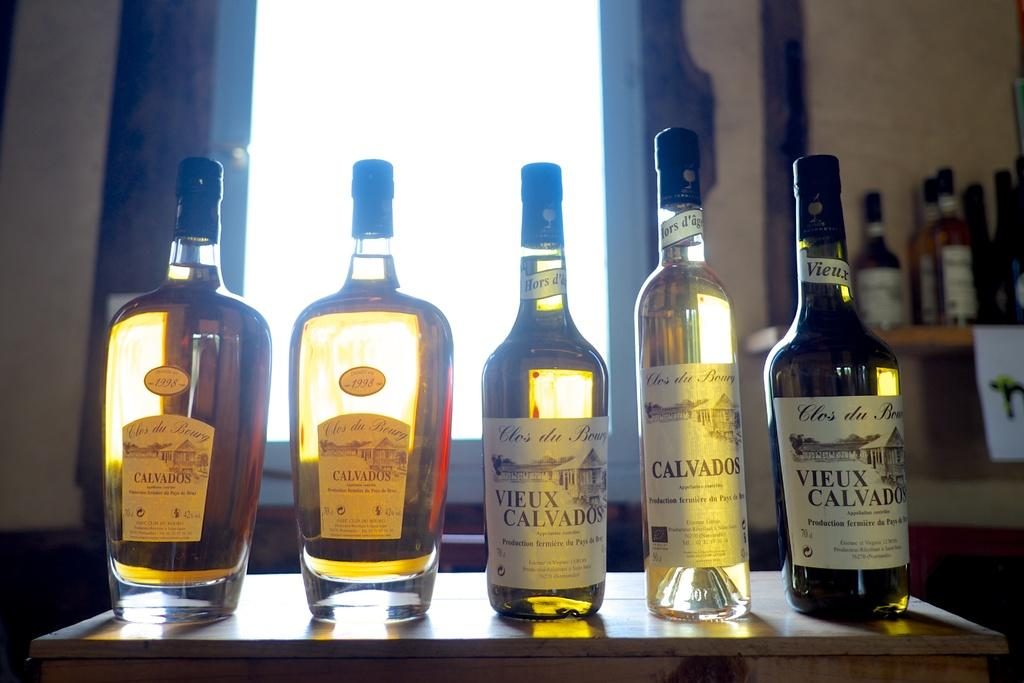<image>
Relay a brief, clear account of the picture shown. 5 bottles of Vieux Calvados wine on a table in front of a window. 